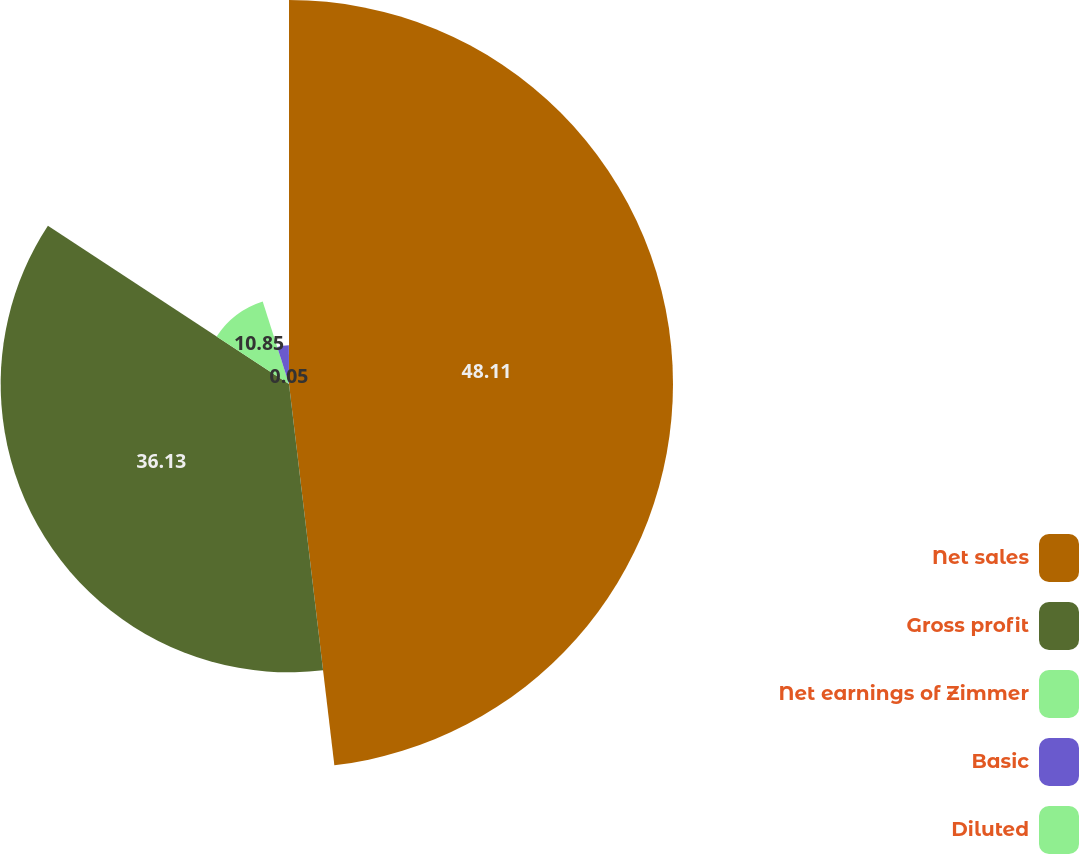Convert chart. <chart><loc_0><loc_0><loc_500><loc_500><pie_chart><fcel>Net sales<fcel>Gross profit<fcel>Net earnings of Zimmer<fcel>Basic<fcel>Diluted<nl><fcel>48.12%<fcel>36.13%<fcel>10.85%<fcel>4.86%<fcel>0.05%<nl></chart> 